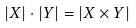<formula> <loc_0><loc_0><loc_500><loc_500>| X | \cdot | Y | = | X \times Y |</formula> 